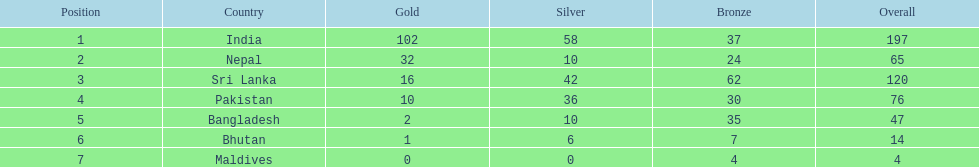Name the first country on the table? India. 